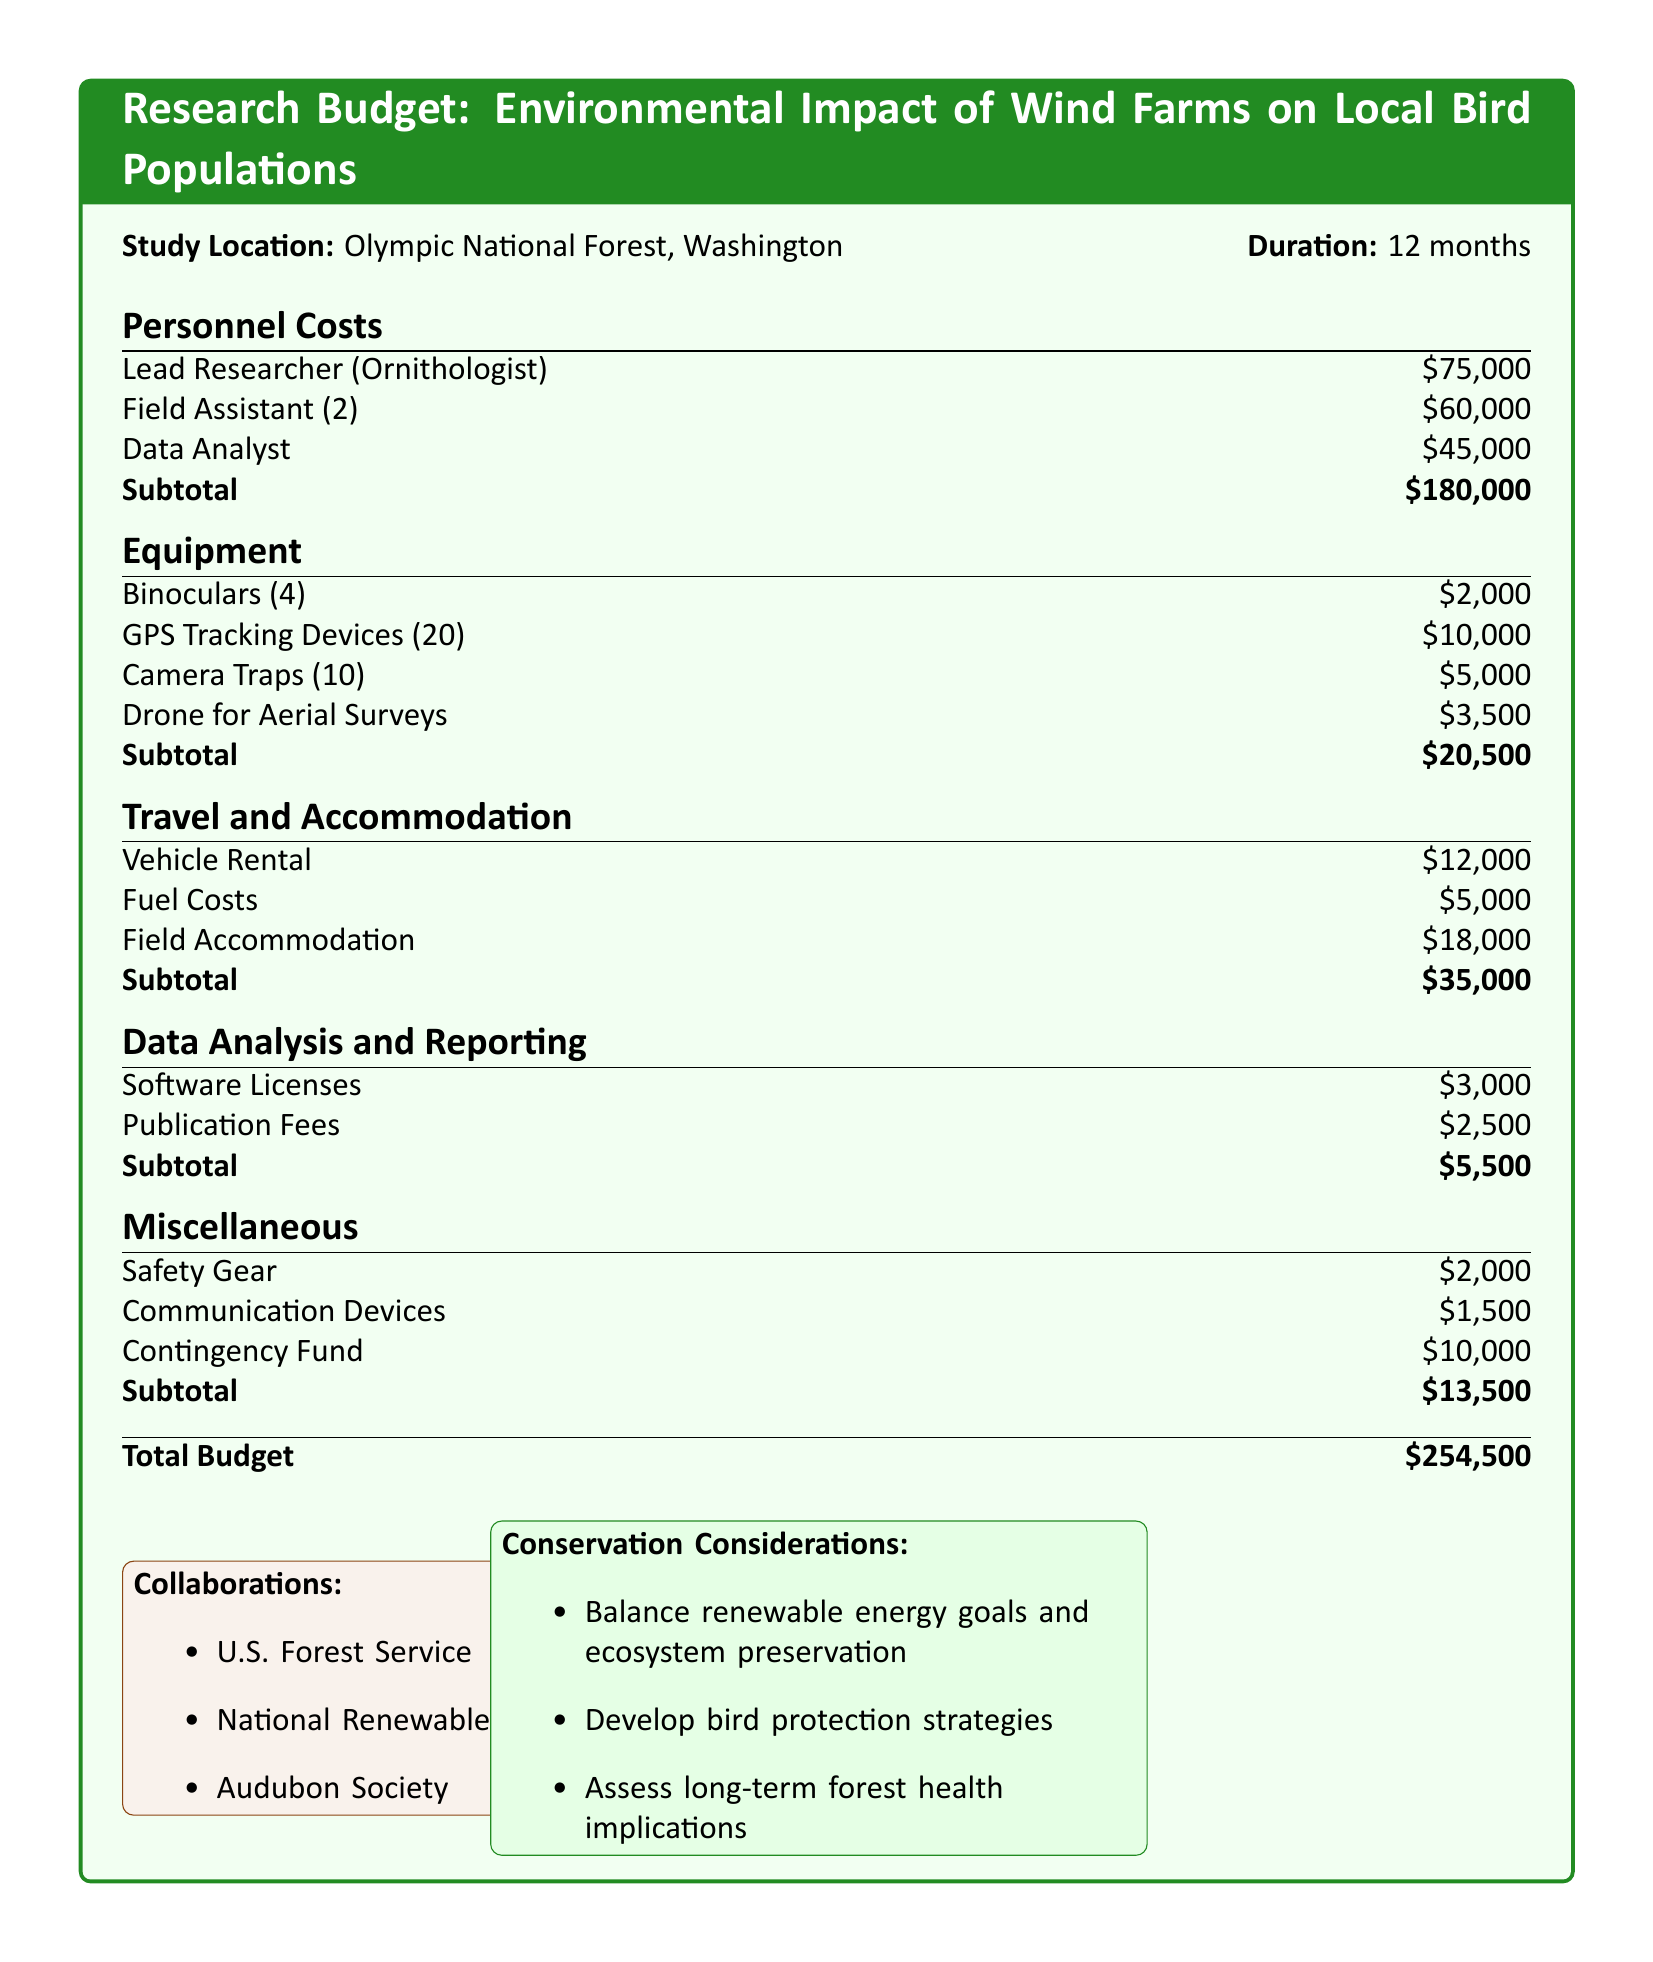what is the total budget? The total budget is presented in the document as the sum of all the costs listed, which is $254,500.
Answer: $254,500 how many field assistants are included? The document specifies that there are 2 field assistants included in the personnel costs.
Answer: 2 what is the cost of GPS tracking devices? The cost for GPS tracking devices is listed as $10,000 in the equipment section.
Answer: $10,000 which organization is collaborating on this research? The document mentions collaborations with organizations such as the U.S. Forest Service, so this is an example of a collaborating organization.
Answer: U.S. Forest Service what is the subtotal for travel and accommodation? The travel and accommodation subtotal is directly stated in the document as $35,000.
Answer: $35,000 what are the conservation considerations listed? The document lists various conservation considerations such as balancing renewable energy goals and ecosystem preservation, which needs to be recognized when evaluating efforts.
Answer: Balance renewable energy goals and ecosystem preservation how much is allocated for safety gear? The document indicates that the amount allocated for safety gear is $2,000 as part of miscellaneous costs.
Answer: $2,000 what is the duration of the study? The duration of the study is given in the document as 12 months, providing a clear timeline for the research efforts.
Answer: 12 months who is the lead researcher? The document identifies the lead researcher as an ornithologist, which is an important role in the research study.
Answer: Ornithologist how many camera traps are planned for use? The budget specifies that 10 camera traps will be utilized in the research, an important detail for equipment planning.
Answer: 10 